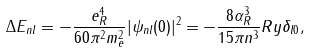Convert formula to latex. <formula><loc_0><loc_0><loc_500><loc_500>\Delta E _ { n l } = - \frac { e _ { R } ^ { 4 } } { 6 0 \pi ^ { 2 } m _ { e } ^ { 2 } } | \psi _ { n l } ( 0 ) | ^ { 2 } = - \frac { 8 \alpha ^ { 3 } _ { R } } { 1 5 \pi n ^ { 3 } } R y \delta _ { l 0 } ,</formula> 